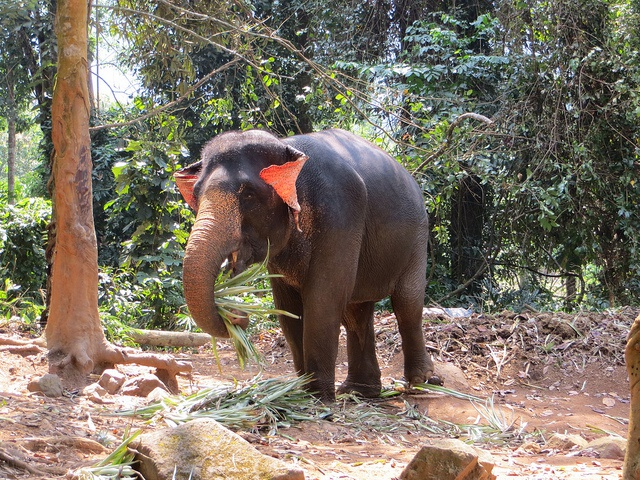Describe the objects in this image and their specific colors. I can see a elephant in gray, black, and maroon tones in this image. 